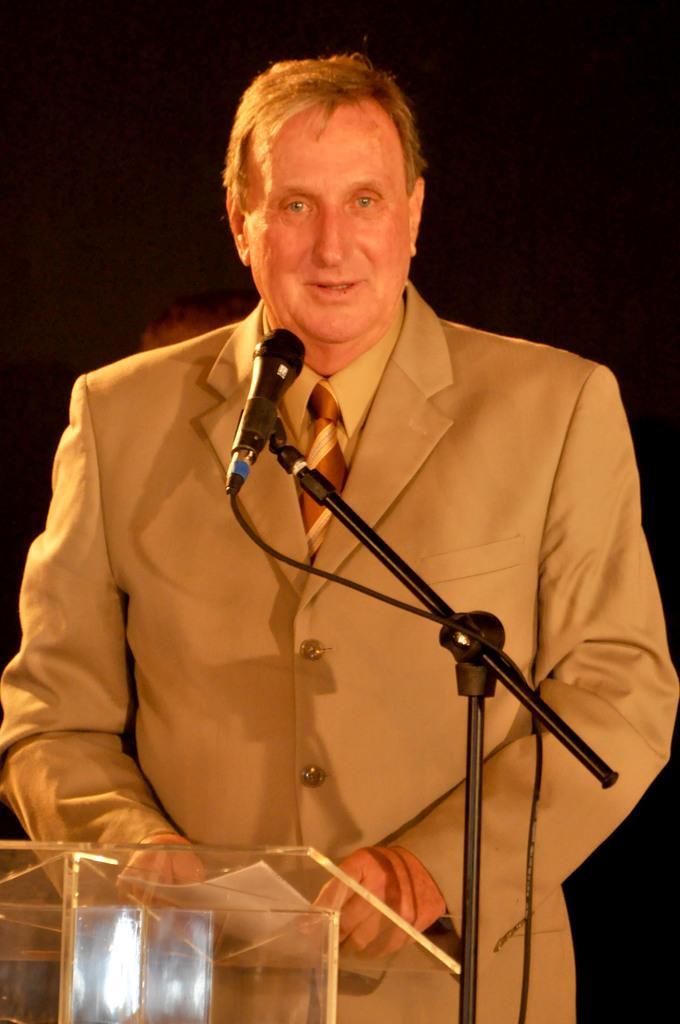Please provide a concise description of this image. In this picture I can see a man standing at a podium and speaking with the help of a microphone and he is holding a paper in his hands and I can see dark background. 